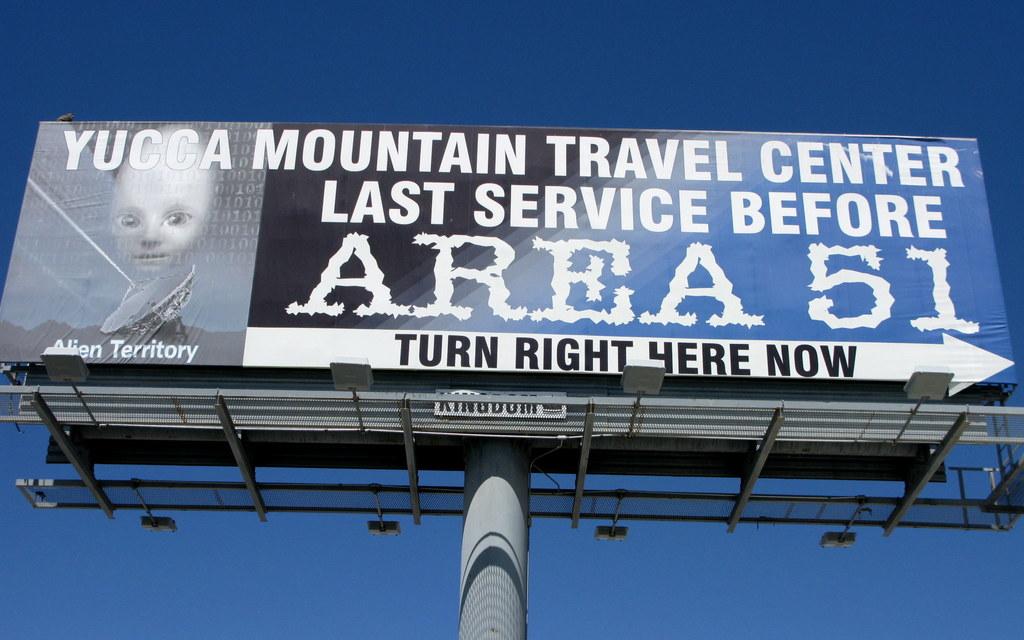Which way should you turn for this attraction?
Give a very brief answer. Right. 